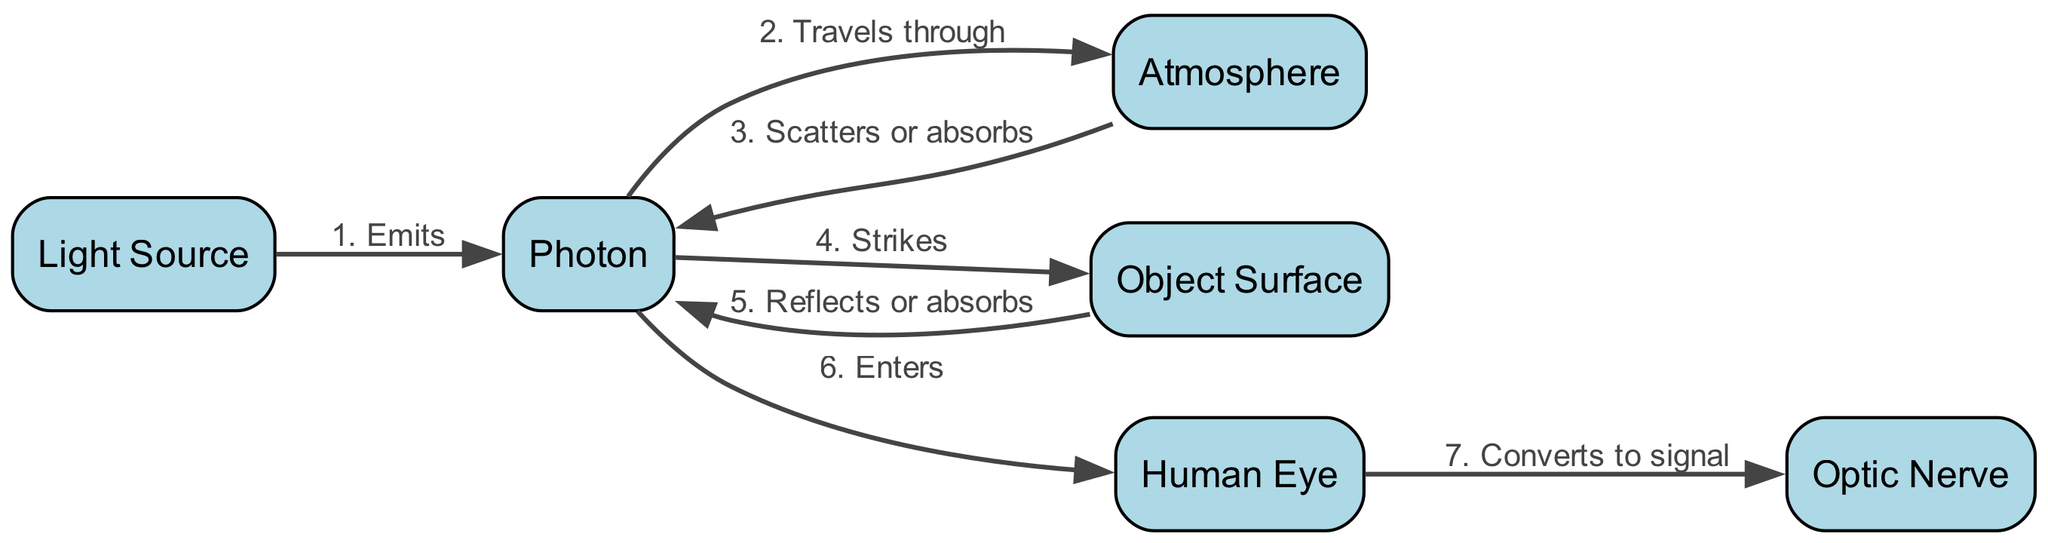What is the first participant in the diagram? The first participant listed in the "participants" section of the diagram is "Light Source."
Answer: Light Source How many steps are there in the photon lifecycle? By counting the entries under the "sequence," we find there are seven distinct steps in the photon lifecycle.
Answer: 7 What action occurs when the photon interacts with the atmosphere? The action specified in the sequence when the photon interacts with the atmosphere is "Scatters or absorbs."
Answer: Scatters or absorbs Which participant does the photon strike after traveling through the atmosphere? Following the order of the sequence, the participant that the photon strikes after traveling through the atmosphere is "Object Surface."
Answer: Object Surface What happens to the photon when it hits the object surface? According to the sequence, the photon either "Reflects or absorbs" upon striking the object surface.
Answer: Reflects or absorbs What signal conversion occurs after the photon enters the human eye? After entering the human eye, the action taken is to "Convert to signal" as it moves to the optic nerve.
Answer: Convert to signal What is the last participant in the sequence of the photon lifecycle? The last participant in the sequence is "Optic Nerve," which is the last step where conversion occurs.
Answer: Optic Nerve What is the relationship between "Photon" and "Atmosphere" in the diagram? The relationship is that the photon "Travels through" the atmosphere as the second step of its lifecycle.
Answer: Travels through Which two actions happen to the photon after it strikes the object surface? The two possible actions listed in the sequence after the photon strikes the object surface are "Reflects" and "absorbs."
Answer: Reflects or absorbs What is the action that occurs immediately after the emission of the photon? The action that occurs immediately after the emission is that the photon "Travels through" the atmosphere.
Answer: Travels through 